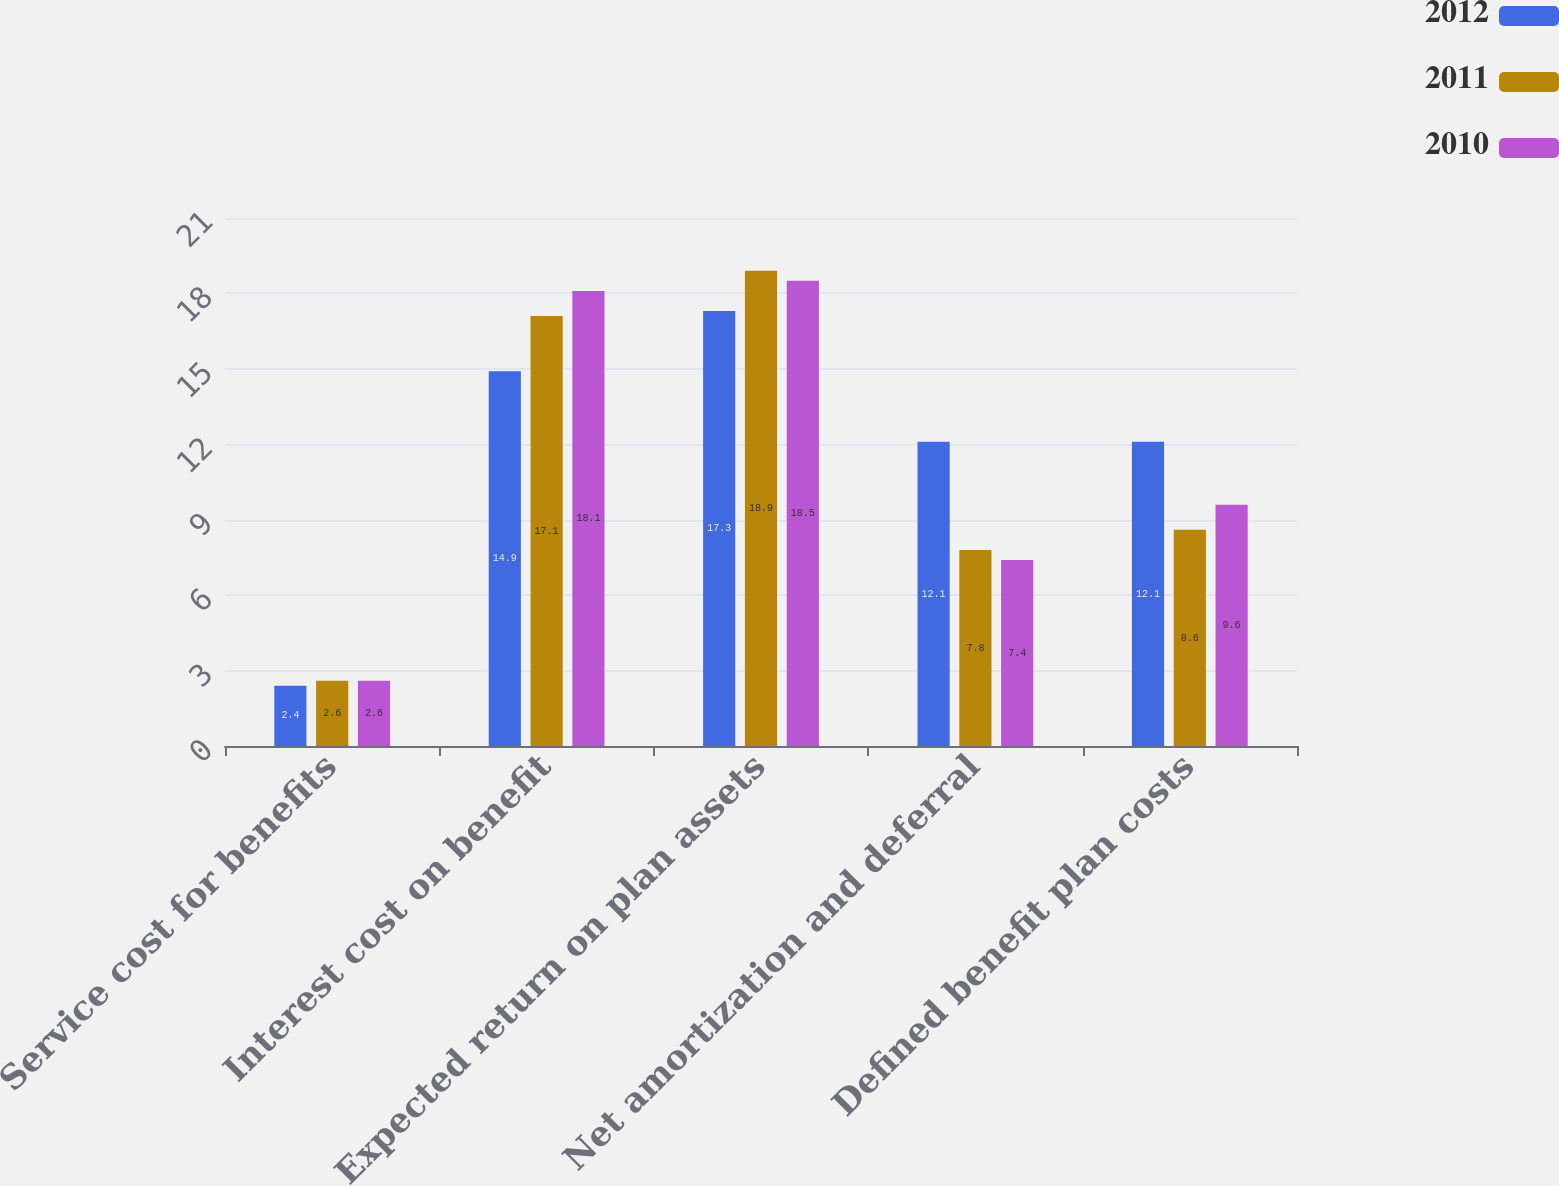Convert chart to OTSL. <chart><loc_0><loc_0><loc_500><loc_500><stacked_bar_chart><ecel><fcel>Service cost for benefits<fcel>Interest cost on benefit<fcel>Expected return on plan assets<fcel>Net amortization and deferral<fcel>Defined benefit plan costs<nl><fcel>2012<fcel>2.4<fcel>14.9<fcel>17.3<fcel>12.1<fcel>12.1<nl><fcel>2011<fcel>2.6<fcel>17.1<fcel>18.9<fcel>7.8<fcel>8.6<nl><fcel>2010<fcel>2.6<fcel>18.1<fcel>18.5<fcel>7.4<fcel>9.6<nl></chart> 